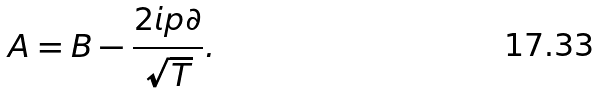<formula> <loc_0><loc_0><loc_500><loc_500>A = B - \frac { 2 i p \partial } { \sqrt { T } } .</formula> 